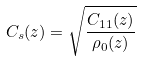<formula> <loc_0><loc_0><loc_500><loc_500>C _ { s } ( z ) = \sqrt { \frac { C _ { 1 1 } ( z ) } { \rho _ { 0 } ( z ) } }</formula> 